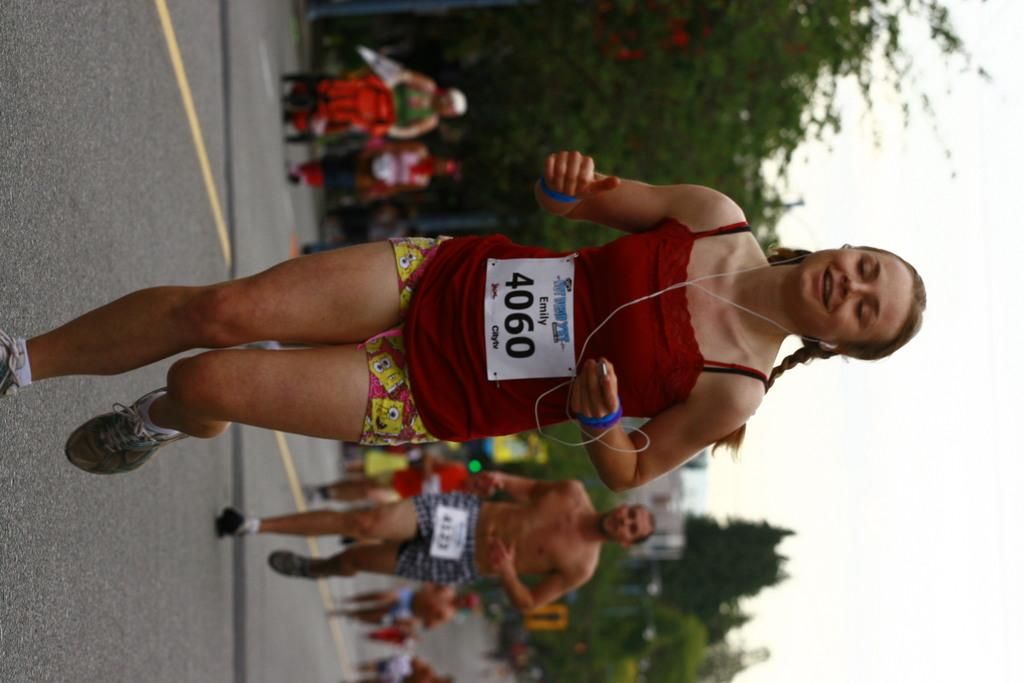<image>
Share a concise interpretation of the image provided. a runner with the name Emily on their tag 